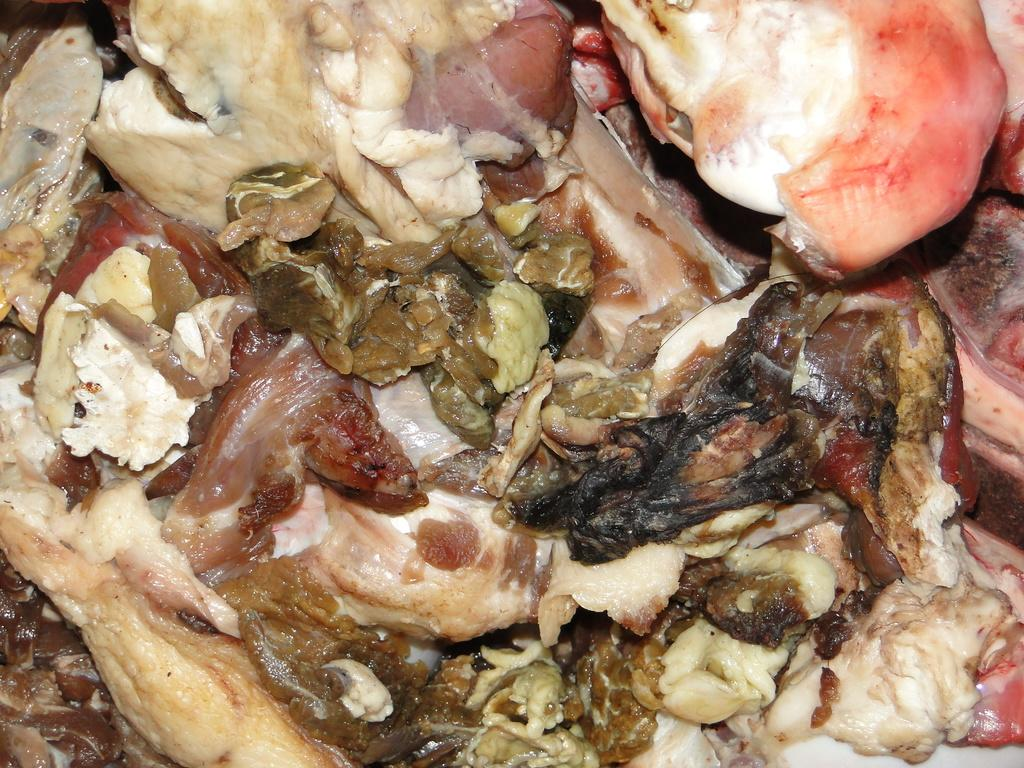What type of food is visible in the image? There is meat in the image. What type of transport is used to deliver the meat in the image? There is no transport visible in the image, as it only shows the meat. Can you see any sidewalks in the image? There is no reference to a sidewalk in the image, as it only shows the meat. 